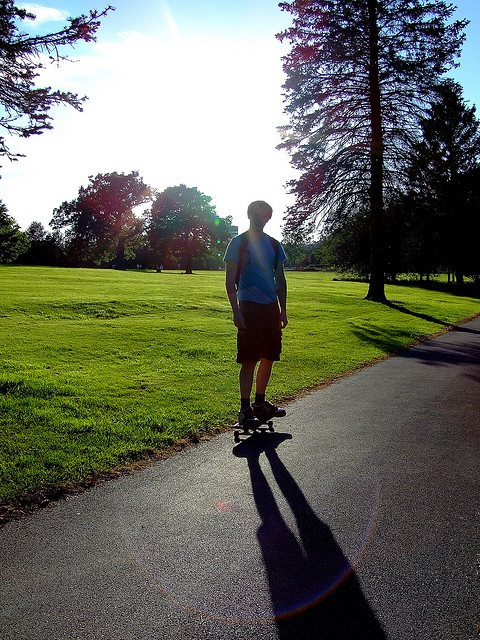Describe the objects in this image and their specific colors. I can see people in teal, black, navy, gray, and blue tones, backpack in teal, black, blue, and gray tones, and skateboard in teal, black, gray, and white tones in this image. 